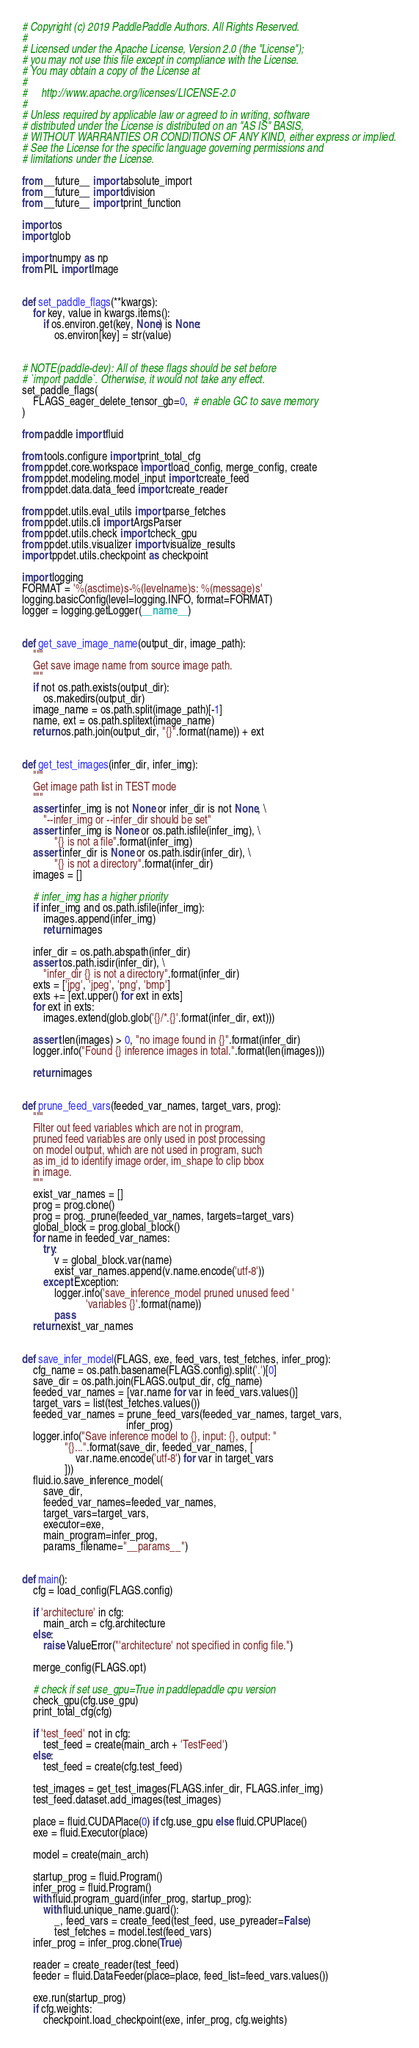<code> <loc_0><loc_0><loc_500><loc_500><_Python_># Copyright (c) 2019 PaddlePaddle Authors. All Rights Reserved.
#
# Licensed under the Apache License, Version 2.0 (the "License");
# you may not use this file except in compliance with the License.
# You may obtain a copy of the License at
#
#     http://www.apache.org/licenses/LICENSE-2.0
#
# Unless required by applicable law or agreed to in writing, software
# distributed under the License is distributed on an "AS IS" BASIS,
# WITHOUT WARRANTIES OR CONDITIONS OF ANY KIND, either express or implied.
# See the License for the specific language governing permissions and
# limitations under the License.

from __future__ import absolute_import
from __future__ import division
from __future__ import print_function

import os
import glob

import numpy as np
from PIL import Image


def set_paddle_flags(**kwargs):
    for key, value in kwargs.items():
        if os.environ.get(key, None) is None:
            os.environ[key] = str(value)


# NOTE(paddle-dev): All of these flags should be set before
# `import paddle`. Otherwise, it would not take any effect.
set_paddle_flags(
    FLAGS_eager_delete_tensor_gb=0,  # enable GC to save memory
)

from paddle import fluid

from tools.configure import print_total_cfg
from ppdet.core.workspace import load_config, merge_config, create
from ppdet.modeling.model_input import create_feed
from ppdet.data.data_feed import create_reader

from ppdet.utils.eval_utils import parse_fetches
from ppdet.utils.cli import ArgsParser
from ppdet.utils.check import check_gpu
from ppdet.utils.visualizer import visualize_results
import ppdet.utils.checkpoint as checkpoint

import logging
FORMAT = '%(asctime)s-%(levelname)s: %(message)s'
logging.basicConfig(level=logging.INFO, format=FORMAT)
logger = logging.getLogger(__name__)


def get_save_image_name(output_dir, image_path):
    """
    Get save image name from source image path.
    """
    if not os.path.exists(output_dir):
        os.makedirs(output_dir)
    image_name = os.path.split(image_path)[-1]
    name, ext = os.path.splitext(image_name)
    return os.path.join(output_dir, "{}".format(name)) + ext


def get_test_images(infer_dir, infer_img):
    """
    Get image path list in TEST mode
    """
    assert infer_img is not None or infer_dir is not None, \
        "--infer_img or --infer_dir should be set"
    assert infer_img is None or os.path.isfile(infer_img), \
            "{} is not a file".format(infer_img)
    assert infer_dir is None or os.path.isdir(infer_dir), \
            "{} is not a directory".format(infer_dir)
    images = []

    # infer_img has a higher priority
    if infer_img and os.path.isfile(infer_img):
        images.append(infer_img)
        return images

    infer_dir = os.path.abspath(infer_dir)
    assert os.path.isdir(infer_dir), \
        "infer_dir {} is not a directory".format(infer_dir)
    exts = ['jpg', 'jpeg', 'png', 'bmp']
    exts += [ext.upper() for ext in exts]
    for ext in exts:
        images.extend(glob.glob('{}/*.{}'.format(infer_dir, ext)))

    assert len(images) > 0, "no image found in {}".format(infer_dir)
    logger.info("Found {} inference images in total.".format(len(images)))

    return images


def prune_feed_vars(feeded_var_names, target_vars, prog):
    """
    Filter out feed variables which are not in program,
    pruned feed variables are only used in post processing
    on model output, which are not used in program, such
    as im_id to identify image order, im_shape to clip bbox
    in image.
    """
    exist_var_names = []
    prog = prog.clone()
    prog = prog._prune(feeded_var_names, targets=target_vars)
    global_block = prog.global_block()
    for name in feeded_var_names:
        try:
            v = global_block.var(name)
            exist_var_names.append(v.name.encode('utf-8'))
        except Exception:
            logger.info('save_inference_model pruned unused feed '
                        'variables {}'.format(name))
            pass
    return exist_var_names


def save_infer_model(FLAGS, exe, feed_vars, test_fetches, infer_prog):
    cfg_name = os.path.basename(FLAGS.config).split('.')[0]
    save_dir = os.path.join(FLAGS.output_dir, cfg_name)
    feeded_var_names = [var.name for var in feed_vars.values()]
    target_vars = list(test_fetches.values())
    feeded_var_names = prune_feed_vars(feeded_var_names, target_vars,
                                       infer_prog)
    logger.info("Save inference model to {}, input: {}, output: "
                "{}...".format(save_dir, feeded_var_names, [
                    var.name.encode('utf-8') for var in target_vars
                ]))
    fluid.io.save_inference_model(
        save_dir,
        feeded_var_names=feeded_var_names,
        target_vars=target_vars,
        executor=exe,
        main_program=infer_prog,
        params_filename="__params__")


def main():
    cfg = load_config(FLAGS.config)

    if 'architecture' in cfg:
        main_arch = cfg.architecture
    else:
        raise ValueError("'architecture' not specified in config file.")

    merge_config(FLAGS.opt)

    # check if set use_gpu=True in paddlepaddle cpu version
    check_gpu(cfg.use_gpu)
    print_total_cfg(cfg)

    if 'test_feed' not in cfg:
        test_feed = create(main_arch + 'TestFeed')
    else:
        test_feed = create(cfg.test_feed)

    test_images = get_test_images(FLAGS.infer_dir, FLAGS.infer_img)
    test_feed.dataset.add_images(test_images)

    place = fluid.CUDAPlace(0) if cfg.use_gpu else fluid.CPUPlace()
    exe = fluid.Executor(place)

    model = create(main_arch)

    startup_prog = fluid.Program()
    infer_prog = fluid.Program()
    with fluid.program_guard(infer_prog, startup_prog):
        with fluid.unique_name.guard():
            _, feed_vars = create_feed(test_feed, use_pyreader=False)
            test_fetches = model.test(feed_vars)
    infer_prog = infer_prog.clone(True)

    reader = create_reader(test_feed)
    feeder = fluid.DataFeeder(place=place, feed_list=feed_vars.values())

    exe.run(startup_prog)
    if cfg.weights:
        checkpoint.load_checkpoint(exe, infer_prog, cfg.weights)
</code> 